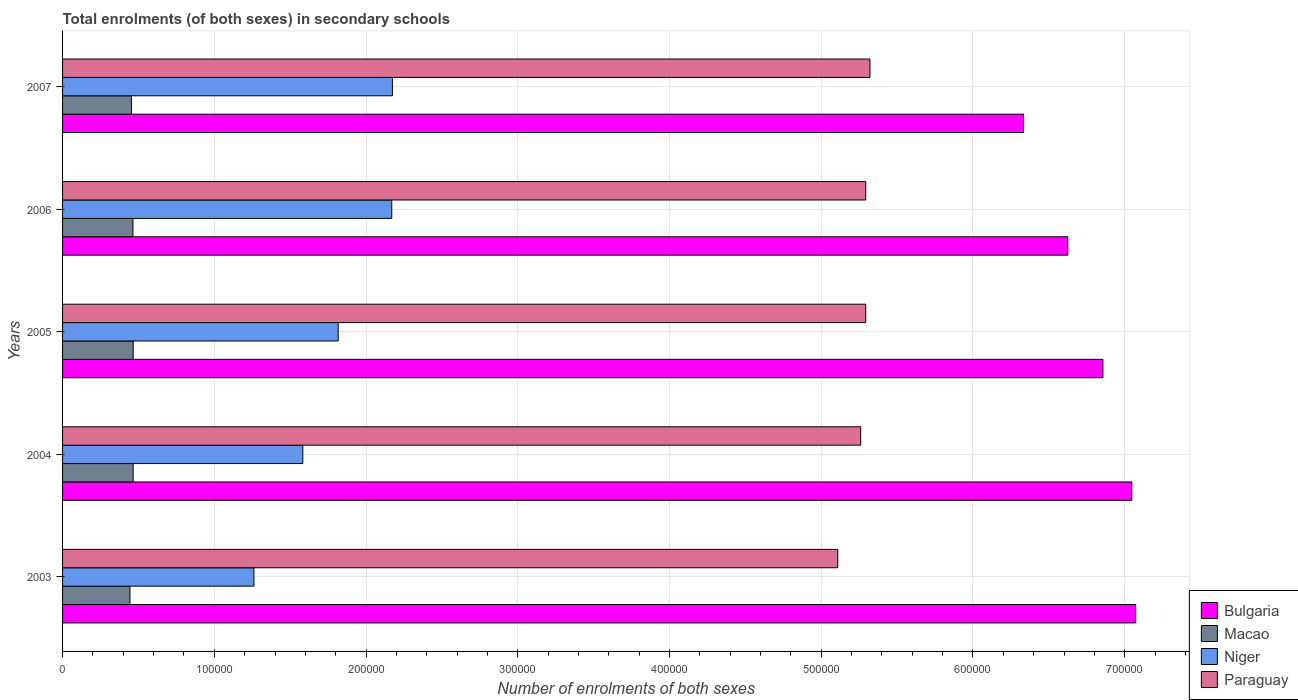Are the number of bars on each tick of the Y-axis equal?
Provide a succinct answer. Yes. How many bars are there on the 1st tick from the bottom?
Provide a short and direct response. 4. What is the number of enrolments in secondary schools in Niger in 2003?
Keep it short and to the point. 1.26e+05. Across all years, what is the maximum number of enrolments in secondary schools in Paraguay?
Ensure brevity in your answer.  5.32e+05. Across all years, what is the minimum number of enrolments in secondary schools in Macao?
Your response must be concise. 4.44e+04. What is the total number of enrolments in secondary schools in Macao in the graph?
Your answer should be compact. 2.29e+05. What is the difference between the number of enrolments in secondary schools in Paraguay in 2003 and that in 2006?
Keep it short and to the point. -1.84e+04. What is the difference between the number of enrolments in secondary schools in Bulgaria in 2005 and the number of enrolments in secondary schools in Macao in 2007?
Provide a short and direct response. 6.40e+05. What is the average number of enrolments in secondary schools in Niger per year?
Provide a short and direct response. 1.80e+05. In the year 2004, what is the difference between the number of enrolments in secondary schools in Bulgaria and number of enrolments in secondary schools in Niger?
Your answer should be compact. 5.46e+05. What is the ratio of the number of enrolments in secondary schools in Paraguay in 2005 to that in 2007?
Ensure brevity in your answer.  0.99. Is the number of enrolments in secondary schools in Macao in 2003 less than that in 2005?
Provide a succinct answer. Yes. Is the difference between the number of enrolments in secondary schools in Bulgaria in 2004 and 2005 greater than the difference between the number of enrolments in secondary schools in Niger in 2004 and 2005?
Offer a very short reply. Yes. What is the difference between the highest and the second highest number of enrolments in secondary schools in Niger?
Offer a terse response. 417. What is the difference between the highest and the lowest number of enrolments in secondary schools in Paraguay?
Keep it short and to the point. 2.12e+04. Is it the case that in every year, the sum of the number of enrolments in secondary schools in Paraguay and number of enrolments in secondary schools in Niger is greater than the sum of number of enrolments in secondary schools in Bulgaria and number of enrolments in secondary schools in Macao?
Your answer should be very brief. Yes. What does the 4th bar from the top in 2006 represents?
Make the answer very short. Bulgaria. What does the 4th bar from the bottom in 2005 represents?
Your answer should be compact. Paraguay. How many years are there in the graph?
Provide a succinct answer. 5. Does the graph contain any zero values?
Ensure brevity in your answer.  No. What is the title of the graph?
Provide a short and direct response. Total enrolments (of both sexes) in secondary schools. What is the label or title of the X-axis?
Make the answer very short. Number of enrolments of both sexes. What is the label or title of the Y-axis?
Your answer should be very brief. Years. What is the Number of enrolments of both sexes in Bulgaria in 2003?
Offer a terse response. 7.07e+05. What is the Number of enrolments of both sexes of Macao in 2003?
Provide a short and direct response. 4.44e+04. What is the Number of enrolments of both sexes in Niger in 2003?
Keep it short and to the point. 1.26e+05. What is the Number of enrolments of both sexes in Paraguay in 2003?
Offer a terse response. 5.11e+05. What is the Number of enrolments of both sexes of Bulgaria in 2004?
Your answer should be very brief. 7.05e+05. What is the Number of enrolments of both sexes in Macao in 2004?
Make the answer very short. 4.65e+04. What is the Number of enrolments of both sexes in Niger in 2004?
Provide a succinct answer. 1.58e+05. What is the Number of enrolments of both sexes of Paraguay in 2004?
Your answer should be very brief. 5.26e+05. What is the Number of enrolments of both sexes in Bulgaria in 2005?
Your response must be concise. 6.86e+05. What is the Number of enrolments of both sexes of Macao in 2005?
Give a very brief answer. 4.65e+04. What is the Number of enrolments of both sexes of Niger in 2005?
Offer a very short reply. 1.82e+05. What is the Number of enrolments of both sexes of Paraguay in 2005?
Give a very brief answer. 5.29e+05. What is the Number of enrolments of both sexes of Bulgaria in 2006?
Ensure brevity in your answer.  6.63e+05. What is the Number of enrolments of both sexes of Macao in 2006?
Make the answer very short. 4.64e+04. What is the Number of enrolments of both sexes of Niger in 2006?
Offer a terse response. 2.17e+05. What is the Number of enrolments of both sexes of Paraguay in 2006?
Your response must be concise. 5.29e+05. What is the Number of enrolments of both sexes in Bulgaria in 2007?
Offer a terse response. 6.33e+05. What is the Number of enrolments of both sexes of Macao in 2007?
Your answer should be very brief. 4.54e+04. What is the Number of enrolments of both sexes of Niger in 2007?
Give a very brief answer. 2.17e+05. What is the Number of enrolments of both sexes in Paraguay in 2007?
Offer a very short reply. 5.32e+05. Across all years, what is the maximum Number of enrolments of both sexes in Bulgaria?
Offer a very short reply. 7.07e+05. Across all years, what is the maximum Number of enrolments of both sexes of Macao?
Ensure brevity in your answer.  4.65e+04. Across all years, what is the maximum Number of enrolments of both sexes of Niger?
Offer a very short reply. 2.17e+05. Across all years, what is the maximum Number of enrolments of both sexes in Paraguay?
Give a very brief answer. 5.32e+05. Across all years, what is the minimum Number of enrolments of both sexes in Bulgaria?
Ensure brevity in your answer.  6.33e+05. Across all years, what is the minimum Number of enrolments of both sexes of Macao?
Your answer should be very brief. 4.44e+04. Across all years, what is the minimum Number of enrolments of both sexes of Niger?
Make the answer very short. 1.26e+05. Across all years, what is the minimum Number of enrolments of both sexes of Paraguay?
Your answer should be compact. 5.11e+05. What is the total Number of enrolments of both sexes of Bulgaria in the graph?
Provide a short and direct response. 3.39e+06. What is the total Number of enrolments of both sexes in Macao in the graph?
Make the answer very short. 2.29e+05. What is the total Number of enrolments of both sexes of Niger in the graph?
Your answer should be compact. 9.00e+05. What is the total Number of enrolments of both sexes in Paraguay in the graph?
Your answer should be compact. 2.63e+06. What is the difference between the Number of enrolments of both sexes of Bulgaria in 2003 and that in 2004?
Keep it short and to the point. 2573. What is the difference between the Number of enrolments of both sexes in Macao in 2003 and that in 2004?
Offer a very short reply. -2084. What is the difference between the Number of enrolments of both sexes in Niger in 2003 and that in 2004?
Your response must be concise. -3.22e+04. What is the difference between the Number of enrolments of both sexes of Paraguay in 2003 and that in 2004?
Ensure brevity in your answer.  -1.51e+04. What is the difference between the Number of enrolments of both sexes in Bulgaria in 2003 and that in 2005?
Offer a terse response. 2.16e+04. What is the difference between the Number of enrolments of both sexes in Macao in 2003 and that in 2005?
Provide a succinct answer. -2114. What is the difference between the Number of enrolments of both sexes in Niger in 2003 and that in 2005?
Your answer should be compact. -5.55e+04. What is the difference between the Number of enrolments of both sexes of Paraguay in 2003 and that in 2005?
Your answer should be very brief. -1.84e+04. What is the difference between the Number of enrolments of both sexes in Bulgaria in 2003 and that in 2006?
Offer a terse response. 4.47e+04. What is the difference between the Number of enrolments of both sexes of Macao in 2003 and that in 2006?
Offer a very short reply. -1968. What is the difference between the Number of enrolments of both sexes of Niger in 2003 and that in 2006?
Make the answer very short. -9.08e+04. What is the difference between the Number of enrolments of both sexes in Paraguay in 2003 and that in 2006?
Your answer should be very brief. -1.84e+04. What is the difference between the Number of enrolments of both sexes in Bulgaria in 2003 and that in 2007?
Provide a short and direct response. 7.39e+04. What is the difference between the Number of enrolments of both sexes in Macao in 2003 and that in 2007?
Keep it short and to the point. -985. What is the difference between the Number of enrolments of both sexes in Niger in 2003 and that in 2007?
Your response must be concise. -9.12e+04. What is the difference between the Number of enrolments of both sexes of Paraguay in 2003 and that in 2007?
Your answer should be very brief. -2.12e+04. What is the difference between the Number of enrolments of both sexes in Bulgaria in 2004 and that in 2005?
Provide a succinct answer. 1.90e+04. What is the difference between the Number of enrolments of both sexes of Niger in 2004 and that in 2005?
Your answer should be very brief. -2.33e+04. What is the difference between the Number of enrolments of both sexes of Paraguay in 2004 and that in 2005?
Your response must be concise. -3308. What is the difference between the Number of enrolments of both sexes in Bulgaria in 2004 and that in 2006?
Provide a succinct answer. 4.22e+04. What is the difference between the Number of enrolments of both sexes of Macao in 2004 and that in 2006?
Your response must be concise. 116. What is the difference between the Number of enrolments of both sexes in Niger in 2004 and that in 2006?
Ensure brevity in your answer.  -5.86e+04. What is the difference between the Number of enrolments of both sexes in Paraguay in 2004 and that in 2006?
Your answer should be compact. -3328. What is the difference between the Number of enrolments of both sexes in Bulgaria in 2004 and that in 2007?
Ensure brevity in your answer.  7.13e+04. What is the difference between the Number of enrolments of both sexes in Macao in 2004 and that in 2007?
Your response must be concise. 1099. What is the difference between the Number of enrolments of both sexes in Niger in 2004 and that in 2007?
Make the answer very short. -5.90e+04. What is the difference between the Number of enrolments of both sexes of Paraguay in 2004 and that in 2007?
Provide a short and direct response. -6102. What is the difference between the Number of enrolments of both sexes in Bulgaria in 2005 and that in 2006?
Make the answer very short. 2.31e+04. What is the difference between the Number of enrolments of both sexes in Macao in 2005 and that in 2006?
Offer a terse response. 146. What is the difference between the Number of enrolments of both sexes of Niger in 2005 and that in 2006?
Your response must be concise. -3.53e+04. What is the difference between the Number of enrolments of both sexes of Paraguay in 2005 and that in 2006?
Your response must be concise. -20. What is the difference between the Number of enrolments of both sexes in Bulgaria in 2005 and that in 2007?
Keep it short and to the point. 5.23e+04. What is the difference between the Number of enrolments of both sexes in Macao in 2005 and that in 2007?
Give a very brief answer. 1129. What is the difference between the Number of enrolments of both sexes in Niger in 2005 and that in 2007?
Make the answer very short. -3.57e+04. What is the difference between the Number of enrolments of both sexes of Paraguay in 2005 and that in 2007?
Make the answer very short. -2794. What is the difference between the Number of enrolments of both sexes in Bulgaria in 2006 and that in 2007?
Your response must be concise. 2.92e+04. What is the difference between the Number of enrolments of both sexes in Macao in 2006 and that in 2007?
Give a very brief answer. 983. What is the difference between the Number of enrolments of both sexes of Niger in 2006 and that in 2007?
Offer a very short reply. -417. What is the difference between the Number of enrolments of both sexes of Paraguay in 2006 and that in 2007?
Give a very brief answer. -2774. What is the difference between the Number of enrolments of both sexes in Bulgaria in 2003 and the Number of enrolments of both sexes in Macao in 2004?
Make the answer very short. 6.61e+05. What is the difference between the Number of enrolments of both sexes of Bulgaria in 2003 and the Number of enrolments of both sexes of Niger in 2004?
Your response must be concise. 5.49e+05. What is the difference between the Number of enrolments of both sexes of Bulgaria in 2003 and the Number of enrolments of both sexes of Paraguay in 2004?
Your response must be concise. 1.81e+05. What is the difference between the Number of enrolments of both sexes in Macao in 2003 and the Number of enrolments of both sexes in Niger in 2004?
Ensure brevity in your answer.  -1.14e+05. What is the difference between the Number of enrolments of both sexes in Macao in 2003 and the Number of enrolments of both sexes in Paraguay in 2004?
Offer a very short reply. -4.82e+05. What is the difference between the Number of enrolments of both sexes of Niger in 2003 and the Number of enrolments of both sexes of Paraguay in 2004?
Offer a terse response. -4.00e+05. What is the difference between the Number of enrolments of both sexes of Bulgaria in 2003 and the Number of enrolments of both sexes of Macao in 2005?
Your answer should be compact. 6.61e+05. What is the difference between the Number of enrolments of both sexes of Bulgaria in 2003 and the Number of enrolments of both sexes of Niger in 2005?
Give a very brief answer. 5.26e+05. What is the difference between the Number of enrolments of both sexes in Bulgaria in 2003 and the Number of enrolments of both sexes in Paraguay in 2005?
Give a very brief answer. 1.78e+05. What is the difference between the Number of enrolments of both sexes of Macao in 2003 and the Number of enrolments of both sexes of Niger in 2005?
Offer a very short reply. -1.37e+05. What is the difference between the Number of enrolments of both sexes in Macao in 2003 and the Number of enrolments of both sexes in Paraguay in 2005?
Your answer should be very brief. -4.85e+05. What is the difference between the Number of enrolments of both sexes of Niger in 2003 and the Number of enrolments of both sexes of Paraguay in 2005?
Make the answer very short. -4.03e+05. What is the difference between the Number of enrolments of both sexes of Bulgaria in 2003 and the Number of enrolments of both sexes of Macao in 2006?
Make the answer very short. 6.61e+05. What is the difference between the Number of enrolments of both sexes of Bulgaria in 2003 and the Number of enrolments of both sexes of Niger in 2006?
Provide a short and direct response. 4.90e+05. What is the difference between the Number of enrolments of both sexes of Bulgaria in 2003 and the Number of enrolments of both sexes of Paraguay in 2006?
Ensure brevity in your answer.  1.78e+05. What is the difference between the Number of enrolments of both sexes of Macao in 2003 and the Number of enrolments of both sexes of Niger in 2006?
Provide a short and direct response. -1.73e+05. What is the difference between the Number of enrolments of both sexes in Macao in 2003 and the Number of enrolments of both sexes in Paraguay in 2006?
Provide a short and direct response. -4.85e+05. What is the difference between the Number of enrolments of both sexes in Niger in 2003 and the Number of enrolments of both sexes in Paraguay in 2006?
Your response must be concise. -4.03e+05. What is the difference between the Number of enrolments of both sexes in Bulgaria in 2003 and the Number of enrolments of both sexes in Macao in 2007?
Your response must be concise. 6.62e+05. What is the difference between the Number of enrolments of both sexes of Bulgaria in 2003 and the Number of enrolments of both sexes of Niger in 2007?
Provide a short and direct response. 4.90e+05. What is the difference between the Number of enrolments of both sexes of Bulgaria in 2003 and the Number of enrolments of both sexes of Paraguay in 2007?
Your response must be concise. 1.75e+05. What is the difference between the Number of enrolments of both sexes in Macao in 2003 and the Number of enrolments of both sexes in Niger in 2007?
Give a very brief answer. -1.73e+05. What is the difference between the Number of enrolments of both sexes of Macao in 2003 and the Number of enrolments of both sexes of Paraguay in 2007?
Offer a terse response. -4.88e+05. What is the difference between the Number of enrolments of both sexes in Niger in 2003 and the Number of enrolments of both sexes in Paraguay in 2007?
Offer a terse response. -4.06e+05. What is the difference between the Number of enrolments of both sexes of Bulgaria in 2004 and the Number of enrolments of both sexes of Macao in 2005?
Offer a terse response. 6.58e+05. What is the difference between the Number of enrolments of both sexes in Bulgaria in 2004 and the Number of enrolments of both sexes in Niger in 2005?
Your answer should be very brief. 5.23e+05. What is the difference between the Number of enrolments of both sexes in Bulgaria in 2004 and the Number of enrolments of both sexes in Paraguay in 2005?
Make the answer very short. 1.75e+05. What is the difference between the Number of enrolments of both sexes in Macao in 2004 and the Number of enrolments of both sexes in Niger in 2005?
Keep it short and to the point. -1.35e+05. What is the difference between the Number of enrolments of both sexes of Macao in 2004 and the Number of enrolments of both sexes of Paraguay in 2005?
Your response must be concise. -4.83e+05. What is the difference between the Number of enrolments of both sexes in Niger in 2004 and the Number of enrolments of both sexes in Paraguay in 2005?
Your answer should be compact. -3.71e+05. What is the difference between the Number of enrolments of both sexes in Bulgaria in 2004 and the Number of enrolments of both sexes in Macao in 2006?
Offer a very short reply. 6.58e+05. What is the difference between the Number of enrolments of both sexes of Bulgaria in 2004 and the Number of enrolments of both sexes of Niger in 2006?
Ensure brevity in your answer.  4.88e+05. What is the difference between the Number of enrolments of both sexes in Bulgaria in 2004 and the Number of enrolments of both sexes in Paraguay in 2006?
Provide a short and direct response. 1.75e+05. What is the difference between the Number of enrolments of both sexes in Macao in 2004 and the Number of enrolments of both sexes in Niger in 2006?
Your answer should be compact. -1.70e+05. What is the difference between the Number of enrolments of both sexes in Macao in 2004 and the Number of enrolments of both sexes in Paraguay in 2006?
Offer a terse response. -4.83e+05. What is the difference between the Number of enrolments of both sexes of Niger in 2004 and the Number of enrolments of both sexes of Paraguay in 2006?
Your answer should be compact. -3.71e+05. What is the difference between the Number of enrolments of both sexes of Bulgaria in 2004 and the Number of enrolments of both sexes of Macao in 2007?
Offer a very short reply. 6.59e+05. What is the difference between the Number of enrolments of both sexes in Bulgaria in 2004 and the Number of enrolments of both sexes in Niger in 2007?
Make the answer very short. 4.87e+05. What is the difference between the Number of enrolments of both sexes in Bulgaria in 2004 and the Number of enrolments of both sexes in Paraguay in 2007?
Keep it short and to the point. 1.73e+05. What is the difference between the Number of enrolments of both sexes of Macao in 2004 and the Number of enrolments of both sexes of Niger in 2007?
Give a very brief answer. -1.71e+05. What is the difference between the Number of enrolments of both sexes of Macao in 2004 and the Number of enrolments of both sexes of Paraguay in 2007?
Ensure brevity in your answer.  -4.86e+05. What is the difference between the Number of enrolments of both sexes of Niger in 2004 and the Number of enrolments of both sexes of Paraguay in 2007?
Keep it short and to the point. -3.74e+05. What is the difference between the Number of enrolments of both sexes in Bulgaria in 2005 and the Number of enrolments of both sexes in Macao in 2006?
Provide a succinct answer. 6.39e+05. What is the difference between the Number of enrolments of both sexes in Bulgaria in 2005 and the Number of enrolments of both sexes in Niger in 2006?
Offer a very short reply. 4.69e+05. What is the difference between the Number of enrolments of both sexes of Bulgaria in 2005 and the Number of enrolments of both sexes of Paraguay in 2006?
Your response must be concise. 1.56e+05. What is the difference between the Number of enrolments of both sexes of Macao in 2005 and the Number of enrolments of both sexes of Niger in 2006?
Offer a terse response. -1.70e+05. What is the difference between the Number of enrolments of both sexes in Macao in 2005 and the Number of enrolments of both sexes in Paraguay in 2006?
Your answer should be compact. -4.83e+05. What is the difference between the Number of enrolments of both sexes of Niger in 2005 and the Number of enrolments of both sexes of Paraguay in 2006?
Give a very brief answer. -3.48e+05. What is the difference between the Number of enrolments of both sexes in Bulgaria in 2005 and the Number of enrolments of both sexes in Macao in 2007?
Make the answer very short. 6.40e+05. What is the difference between the Number of enrolments of both sexes of Bulgaria in 2005 and the Number of enrolments of both sexes of Niger in 2007?
Your answer should be very brief. 4.68e+05. What is the difference between the Number of enrolments of both sexes of Bulgaria in 2005 and the Number of enrolments of both sexes of Paraguay in 2007?
Your answer should be compact. 1.54e+05. What is the difference between the Number of enrolments of both sexes in Macao in 2005 and the Number of enrolments of both sexes in Niger in 2007?
Give a very brief answer. -1.71e+05. What is the difference between the Number of enrolments of both sexes of Macao in 2005 and the Number of enrolments of both sexes of Paraguay in 2007?
Your response must be concise. -4.86e+05. What is the difference between the Number of enrolments of both sexes of Niger in 2005 and the Number of enrolments of both sexes of Paraguay in 2007?
Keep it short and to the point. -3.50e+05. What is the difference between the Number of enrolments of both sexes of Bulgaria in 2006 and the Number of enrolments of both sexes of Macao in 2007?
Provide a short and direct response. 6.17e+05. What is the difference between the Number of enrolments of both sexes of Bulgaria in 2006 and the Number of enrolments of both sexes of Niger in 2007?
Your response must be concise. 4.45e+05. What is the difference between the Number of enrolments of both sexes of Bulgaria in 2006 and the Number of enrolments of both sexes of Paraguay in 2007?
Offer a terse response. 1.30e+05. What is the difference between the Number of enrolments of both sexes in Macao in 2006 and the Number of enrolments of both sexes in Niger in 2007?
Give a very brief answer. -1.71e+05. What is the difference between the Number of enrolments of both sexes of Macao in 2006 and the Number of enrolments of both sexes of Paraguay in 2007?
Your response must be concise. -4.86e+05. What is the difference between the Number of enrolments of both sexes in Niger in 2006 and the Number of enrolments of both sexes in Paraguay in 2007?
Your answer should be compact. -3.15e+05. What is the average Number of enrolments of both sexes of Bulgaria per year?
Make the answer very short. 6.79e+05. What is the average Number of enrolments of both sexes in Macao per year?
Ensure brevity in your answer.  4.59e+04. What is the average Number of enrolments of both sexes in Niger per year?
Give a very brief answer. 1.80e+05. What is the average Number of enrolments of both sexes of Paraguay per year?
Offer a terse response. 5.26e+05. In the year 2003, what is the difference between the Number of enrolments of both sexes of Bulgaria and Number of enrolments of both sexes of Macao?
Offer a very short reply. 6.63e+05. In the year 2003, what is the difference between the Number of enrolments of both sexes of Bulgaria and Number of enrolments of both sexes of Niger?
Your response must be concise. 5.81e+05. In the year 2003, what is the difference between the Number of enrolments of both sexes of Bulgaria and Number of enrolments of both sexes of Paraguay?
Your answer should be compact. 1.96e+05. In the year 2003, what is the difference between the Number of enrolments of both sexes of Macao and Number of enrolments of both sexes of Niger?
Your response must be concise. -8.17e+04. In the year 2003, what is the difference between the Number of enrolments of both sexes of Macao and Number of enrolments of both sexes of Paraguay?
Your answer should be compact. -4.66e+05. In the year 2003, what is the difference between the Number of enrolments of both sexes in Niger and Number of enrolments of both sexes in Paraguay?
Offer a terse response. -3.85e+05. In the year 2004, what is the difference between the Number of enrolments of both sexes of Bulgaria and Number of enrolments of both sexes of Macao?
Provide a succinct answer. 6.58e+05. In the year 2004, what is the difference between the Number of enrolments of both sexes of Bulgaria and Number of enrolments of both sexes of Niger?
Keep it short and to the point. 5.46e+05. In the year 2004, what is the difference between the Number of enrolments of both sexes of Bulgaria and Number of enrolments of both sexes of Paraguay?
Keep it short and to the point. 1.79e+05. In the year 2004, what is the difference between the Number of enrolments of both sexes of Macao and Number of enrolments of both sexes of Niger?
Make the answer very short. -1.12e+05. In the year 2004, what is the difference between the Number of enrolments of both sexes of Macao and Number of enrolments of both sexes of Paraguay?
Your answer should be very brief. -4.79e+05. In the year 2004, what is the difference between the Number of enrolments of both sexes of Niger and Number of enrolments of both sexes of Paraguay?
Keep it short and to the point. -3.68e+05. In the year 2005, what is the difference between the Number of enrolments of both sexes of Bulgaria and Number of enrolments of both sexes of Macao?
Offer a very short reply. 6.39e+05. In the year 2005, what is the difference between the Number of enrolments of both sexes in Bulgaria and Number of enrolments of both sexes in Niger?
Provide a succinct answer. 5.04e+05. In the year 2005, what is the difference between the Number of enrolments of both sexes in Bulgaria and Number of enrolments of both sexes in Paraguay?
Ensure brevity in your answer.  1.56e+05. In the year 2005, what is the difference between the Number of enrolments of both sexes of Macao and Number of enrolments of both sexes of Niger?
Ensure brevity in your answer.  -1.35e+05. In the year 2005, what is the difference between the Number of enrolments of both sexes of Macao and Number of enrolments of both sexes of Paraguay?
Your response must be concise. -4.83e+05. In the year 2005, what is the difference between the Number of enrolments of both sexes in Niger and Number of enrolments of both sexes in Paraguay?
Provide a succinct answer. -3.48e+05. In the year 2006, what is the difference between the Number of enrolments of both sexes in Bulgaria and Number of enrolments of both sexes in Macao?
Provide a succinct answer. 6.16e+05. In the year 2006, what is the difference between the Number of enrolments of both sexes of Bulgaria and Number of enrolments of both sexes of Niger?
Your response must be concise. 4.46e+05. In the year 2006, what is the difference between the Number of enrolments of both sexes in Bulgaria and Number of enrolments of both sexes in Paraguay?
Offer a terse response. 1.33e+05. In the year 2006, what is the difference between the Number of enrolments of both sexes in Macao and Number of enrolments of both sexes in Niger?
Make the answer very short. -1.71e+05. In the year 2006, what is the difference between the Number of enrolments of both sexes in Macao and Number of enrolments of both sexes in Paraguay?
Offer a terse response. -4.83e+05. In the year 2006, what is the difference between the Number of enrolments of both sexes of Niger and Number of enrolments of both sexes of Paraguay?
Give a very brief answer. -3.12e+05. In the year 2007, what is the difference between the Number of enrolments of both sexes of Bulgaria and Number of enrolments of both sexes of Macao?
Keep it short and to the point. 5.88e+05. In the year 2007, what is the difference between the Number of enrolments of both sexes of Bulgaria and Number of enrolments of both sexes of Niger?
Your response must be concise. 4.16e+05. In the year 2007, what is the difference between the Number of enrolments of both sexes of Bulgaria and Number of enrolments of both sexes of Paraguay?
Provide a short and direct response. 1.01e+05. In the year 2007, what is the difference between the Number of enrolments of both sexes in Macao and Number of enrolments of both sexes in Niger?
Provide a short and direct response. -1.72e+05. In the year 2007, what is the difference between the Number of enrolments of both sexes in Macao and Number of enrolments of both sexes in Paraguay?
Make the answer very short. -4.87e+05. In the year 2007, what is the difference between the Number of enrolments of both sexes in Niger and Number of enrolments of both sexes in Paraguay?
Provide a succinct answer. -3.15e+05. What is the ratio of the Number of enrolments of both sexes in Bulgaria in 2003 to that in 2004?
Provide a succinct answer. 1. What is the ratio of the Number of enrolments of both sexes of Macao in 2003 to that in 2004?
Give a very brief answer. 0.96. What is the ratio of the Number of enrolments of both sexes of Niger in 2003 to that in 2004?
Offer a terse response. 0.8. What is the ratio of the Number of enrolments of both sexes in Paraguay in 2003 to that in 2004?
Give a very brief answer. 0.97. What is the ratio of the Number of enrolments of both sexes in Bulgaria in 2003 to that in 2005?
Make the answer very short. 1.03. What is the ratio of the Number of enrolments of both sexes of Macao in 2003 to that in 2005?
Offer a terse response. 0.95. What is the ratio of the Number of enrolments of both sexes in Niger in 2003 to that in 2005?
Give a very brief answer. 0.69. What is the ratio of the Number of enrolments of both sexes of Paraguay in 2003 to that in 2005?
Offer a very short reply. 0.97. What is the ratio of the Number of enrolments of both sexes in Bulgaria in 2003 to that in 2006?
Provide a short and direct response. 1.07. What is the ratio of the Number of enrolments of both sexes of Macao in 2003 to that in 2006?
Provide a short and direct response. 0.96. What is the ratio of the Number of enrolments of both sexes in Niger in 2003 to that in 2006?
Give a very brief answer. 0.58. What is the ratio of the Number of enrolments of both sexes in Paraguay in 2003 to that in 2006?
Provide a succinct answer. 0.97. What is the ratio of the Number of enrolments of both sexes in Bulgaria in 2003 to that in 2007?
Provide a short and direct response. 1.12. What is the ratio of the Number of enrolments of both sexes in Macao in 2003 to that in 2007?
Your answer should be very brief. 0.98. What is the ratio of the Number of enrolments of both sexes of Niger in 2003 to that in 2007?
Your answer should be compact. 0.58. What is the ratio of the Number of enrolments of both sexes in Paraguay in 2003 to that in 2007?
Your response must be concise. 0.96. What is the ratio of the Number of enrolments of both sexes of Bulgaria in 2004 to that in 2005?
Give a very brief answer. 1.03. What is the ratio of the Number of enrolments of both sexes in Niger in 2004 to that in 2005?
Keep it short and to the point. 0.87. What is the ratio of the Number of enrolments of both sexes in Paraguay in 2004 to that in 2005?
Provide a short and direct response. 0.99. What is the ratio of the Number of enrolments of both sexes of Bulgaria in 2004 to that in 2006?
Keep it short and to the point. 1.06. What is the ratio of the Number of enrolments of both sexes in Niger in 2004 to that in 2006?
Offer a terse response. 0.73. What is the ratio of the Number of enrolments of both sexes of Paraguay in 2004 to that in 2006?
Your answer should be very brief. 0.99. What is the ratio of the Number of enrolments of both sexes of Bulgaria in 2004 to that in 2007?
Your answer should be compact. 1.11. What is the ratio of the Number of enrolments of both sexes in Macao in 2004 to that in 2007?
Provide a succinct answer. 1.02. What is the ratio of the Number of enrolments of both sexes of Niger in 2004 to that in 2007?
Provide a succinct answer. 0.73. What is the ratio of the Number of enrolments of both sexes of Paraguay in 2004 to that in 2007?
Your response must be concise. 0.99. What is the ratio of the Number of enrolments of both sexes in Bulgaria in 2005 to that in 2006?
Provide a short and direct response. 1.03. What is the ratio of the Number of enrolments of both sexes in Macao in 2005 to that in 2006?
Provide a short and direct response. 1. What is the ratio of the Number of enrolments of both sexes of Niger in 2005 to that in 2006?
Give a very brief answer. 0.84. What is the ratio of the Number of enrolments of both sexes in Bulgaria in 2005 to that in 2007?
Give a very brief answer. 1.08. What is the ratio of the Number of enrolments of both sexes of Macao in 2005 to that in 2007?
Make the answer very short. 1.02. What is the ratio of the Number of enrolments of both sexes of Niger in 2005 to that in 2007?
Offer a terse response. 0.84. What is the ratio of the Number of enrolments of both sexes of Bulgaria in 2006 to that in 2007?
Offer a very short reply. 1.05. What is the ratio of the Number of enrolments of both sexes of Macao in 2006 to that in 2007?
Give a very brief answer. 1.02. What is the ratio of the Number of enrolments of both sexes of Paraguay in 2006 to that in 2007?
Offer a terse response. 0.99. What is the difference between the highest and the second highest Number of enrolments of both sexes of Bulgaria?
Your response must be concise. 2573. What is the difference between the highest and the second highest Number of enrolments of both sexes of Niger?
Ensure brevity in your answer.  417. What is the difference between the highest and the second highest Number of enrolments of both sexes of Paraguay?
Provide a short and direct response. 2774. What is the difference between the highest and the lowest Number of enrolments of both sexes of Bulgaria?
Ensure brevity in your answer.  7.39e+04. What is the difference between the highest and the lowest Number of enrolments of both sexes in Macao?
Provide a succinct answer. 2114. What is the difference between the highest and the lowest Number of enrolments of both sexes of Niger?
Your response must be concise. 9.12e+04. What is the difference between the highest and the lowest Number of enrolments of both sexes in Paraguay?
Give a very brief answer. 2.12e+04. 